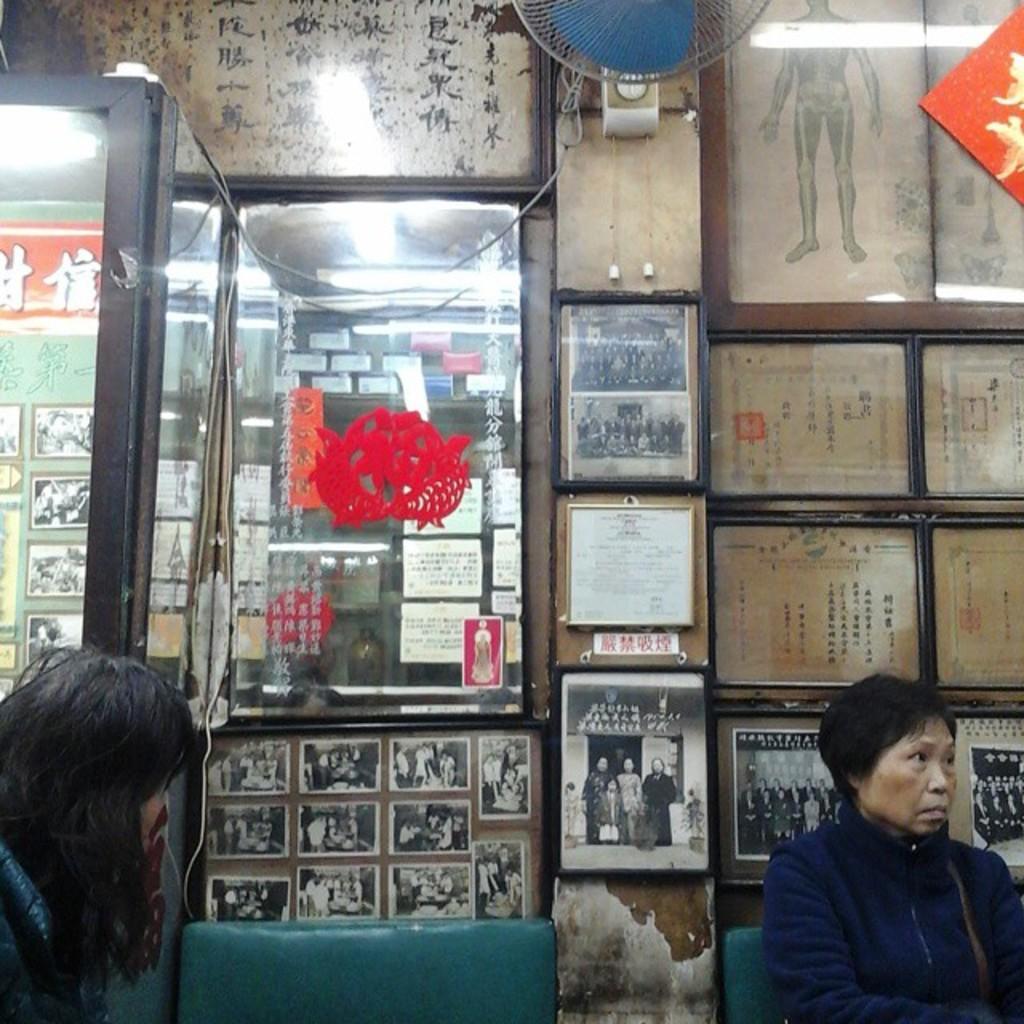Please provide a concise description of this image. In this image, we can see people and there are chairs and one of them is sitting on the chair. In the background, there is a mirror and we can see lights, a table fan, boards and some frames on the wall. 